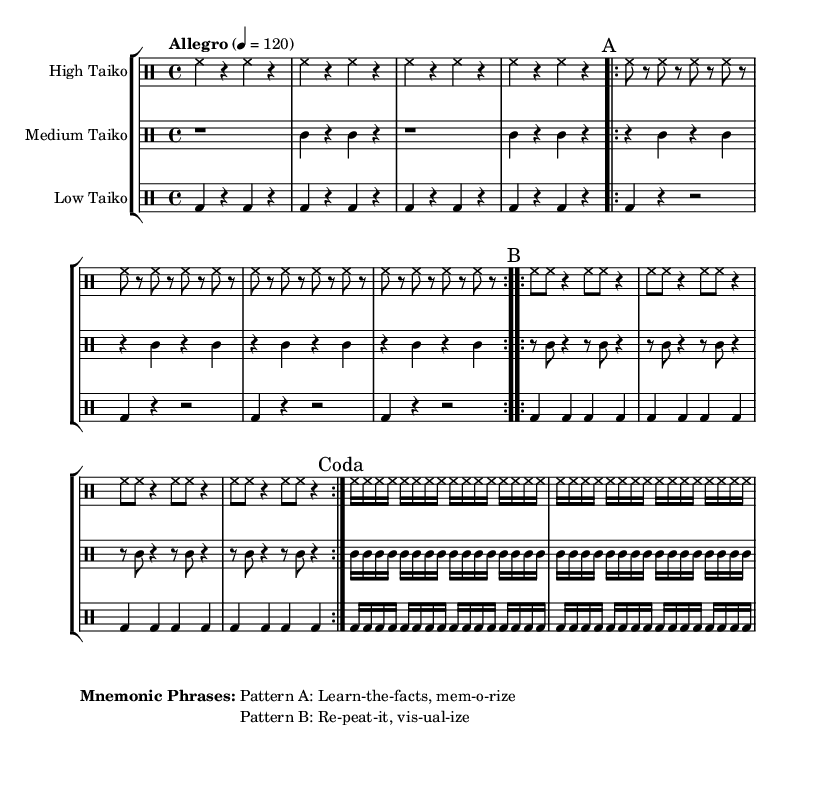What is the time signature of this music? The time signature is indicated at the beginning of the sheet music as 4/4, which means there are four beats per measure and the quarter note gets one beat.
Answer: 4/4 What is the tempo marking for this piece? The tempo is specified in the first system of the score, where it states "Allegro" followed by 4=120, meaning the piece should be played at a lively pace with 120 beats per minute.
Answer: Allegro, 120 What is the first pattern labeled in the music? The first pattern is indicated with the mark "A" in the sheet music, which corresponds to the section made up of eight notes followed by rests.
Answer: A How many times is Pattern B repeated? The music notation shows that Pattern B has a repeat indication, and it is stated to be repeated volta 2, meaning it is played two times.
Answer: 2 Which taiko drum plays the solo introduction? The introduction is played by the High Taiko, as indicated by the label of the drum staff at the beginning of the score and is the first complete measure shown.
Answer: High Taiko What mnemonic phrase is associated with Pattern A? The sheet music includes mnemonic phrases in the markup section. For Pattern A, the phrase is "Learn-the-facts, mem-o-rize."
Answer: Learn-the-facts, mem-o-rize What does the coda consist of? The coda in this sheet music is indicated at the end and consists of repeated sequences of sixteenth notes played by the High, Medium, and Low Taiko drums, creating a concluding rhythm.
Answer: Sixteenth notes repetition 